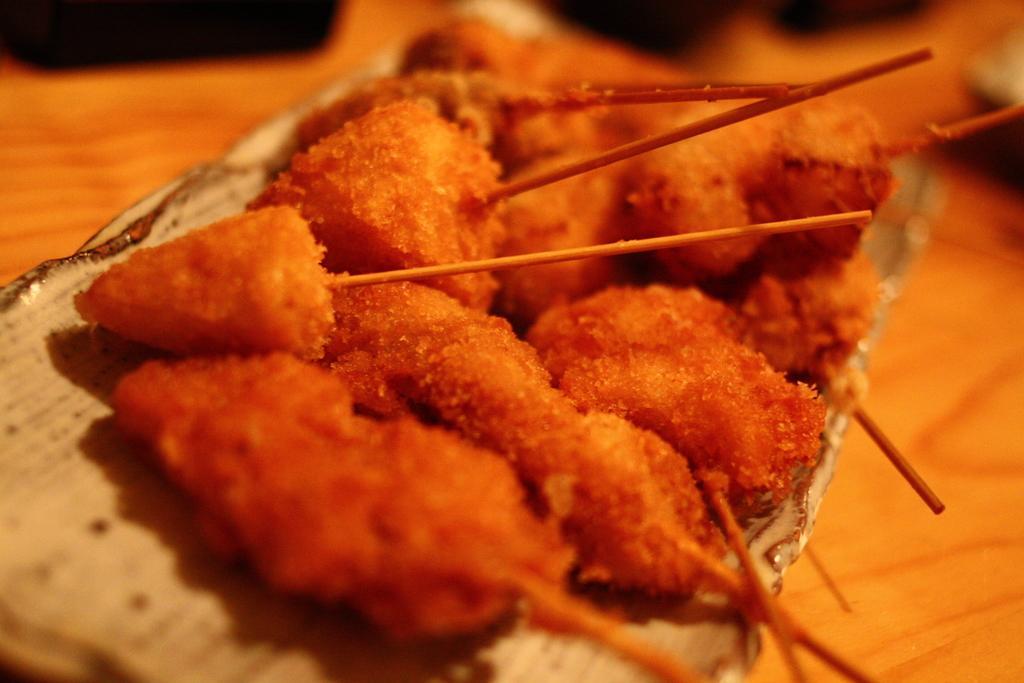In one or two sentences, can you explain what this image depicts? In this image we can see a red color food item, with sticks on a surface. 